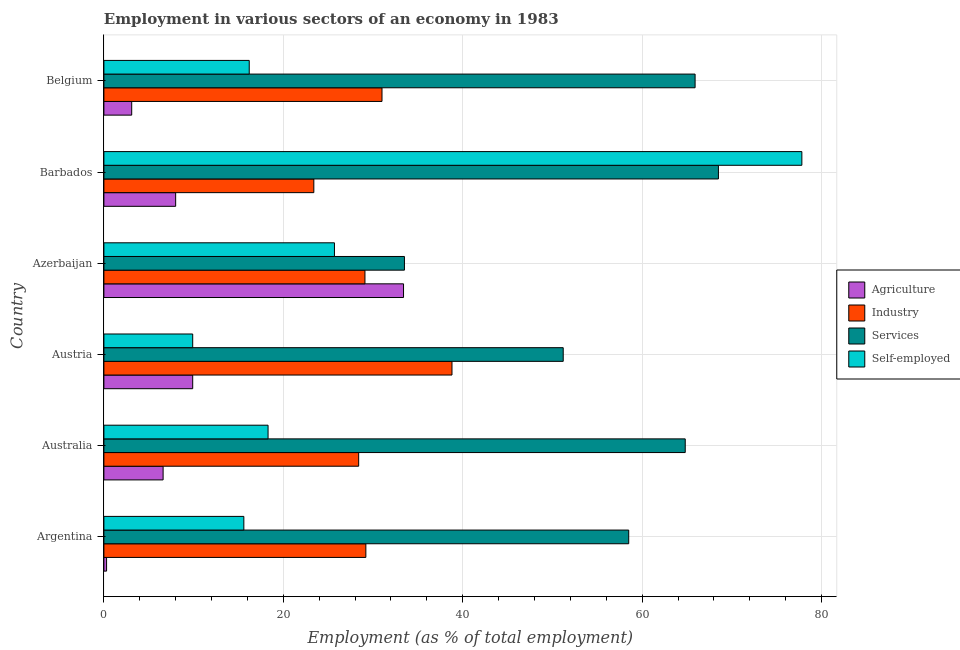How many different coloured bars are there?
Your response must be concise. 4. Are the number of bars on each tick of the Y-axis equal?
Offer a very short reply. Yes. How many bars are there on the 2nd tick from the bottom?
Your answer should be compact. 4. What is the label of the 5th group of bars from the top?
Your answer should be compact. Australia. In how many cases, is the number of bars for a given country not equal to the number of legend labels?
Keep it short and to the point. 0. What is the percentage of workers in industry in Azerbaijan?
Your answer should be compact. 29.1. Across all countries, what is the maximum percentage of self employed workers?
Provide a succinct answer. 77.8. Across all countries, what is the minimum percentage of workers in services?
Your answer should be very brief. 33.5. In which country was the percentage of workers in agriculture minimum?
Keep it short and to the point. Argentina. What is the total percentage of workers in agriculture in the graph?
Offer a terse response. 61.3. What is the difference between the percentage of workers in industry in Argentina and the percentage of workers in services in Azerbaijan?
Provide a succinct answer. -4.3. What is the average percentage of self employed workers per country?
Provide a short and direct response. 27.25. What is the difference between the percentage of self employed workers and percentage of workers in industry in Australia?
Your answer should be very brief. -10.1. What is the ratio of the percentage of workers in services in Argentina to that in Belgium?
Ensure brevity in your answer.  0.89. Is the percentage of workers in industry in Australia less than that in Barbados?
Offer a very short reply. No. What is the difference between the highest and the second highest percentage of workers in industry?
Your response must be concise. 7.8. In how many countries, is the percentage of workers in agriculture greater than the average percentage of workers in agriculture taken over all countries?
Offer a very short reply. 1. Is the sum of the percentage of workers in services in Azerbaijan and Belgium greater than the maximum percentage of workers in agriculture across all countries?
Your answer should be compact. Yes. Is it the case that in every country, the sum of the percentage of workers in agriculture and percentage of workers in services is greater than the sum of percentage of self employed workers and percentage of workers in industry?
Give a very brief answer. Yes. What does the 4th bar from the top in Austria represents?
Offer a very short reply. Agriculture. What does the 2nd bar from the bottom in Australia represents?
Provide a succinct answer. Industry. How many bars are there?
Your answer should be compact. 24. Are all the bars in the graph horizontal?
Make the answer very short. Yes. How many countries are there in the graph?
Your answer should be compact. 6. What is the difference between two consecutive major ticks on the X-axis?
Make the answer very short. 20. Are the values on the major ticks of X-axis written in scientific E-notation?
Your answer should be compact. No. Does the graph contain any zero values?
Give a very brief answer. No. Where does the legend appear in the graph?
Your answer should be very brief. Center right. How many legend labels are there?
Keep it short and to the point. 4. How are the legend labels stacked?
Give a very brief answer. Vertical. What is the title of the graph?
Provide a succinct answer. Employment in various sectors of an economy in 1983. Does "Plant species" appear as one of the legend labels in the graph?
Give a very brief answer. No. What is the label or title of the X-axis?
Ensure brevity in your answer.  Employment (as % of total employment). What is the label or title of the Y-axis?
Keep it short and to the point. Country. What is the Employment (as % of total employment) in Agriculture in Argentina?
Make the answer very short. 0.3. What is the Employment (as % of total employment) of Industry in Argentina?
Provide a succinct answer. 29.2. What is the Employment (as % of total employment) in Services in Argentina?
Provide a succinct answer. 58.5. What is the Employment (as % of total employment) of Self-employed in Argentina?
Your answer should be very brief. 15.6. What is the Employment (as % of total employment) in Agriculture in Australia?
Keep it short and to the point. 6.6. What is the Employment (as % of total employment) of Industry in Australia?
Offer a terse response. 28.4. What is the Employment (as % of total employment) of Services in Australia?
Give a very brief answer. 64.8. What is the Employment (as % of total employment) in Self-employed in Australia?
Your response must be concise. 18.3. What is the Employment (as % of total employment) in Agriculture in Austria?
Ensure brevity in your answer.  9.9. What is the Employment (as % of total employment) in Industry in Austria?
Keep it short and to the point. 38.8. What is the Employment (as % of total employment) of Services in Austria?
Your answer should be very brief. 51.2. What is the Employment (as % of total employment) in Self-employed in Austria?
Your response must be concise. 9.9. What is the Employment (as % of total employment) in Agriculture in Azerbaijan?
Ensure brevity in your answer.  33.4. What is the Employment (as % of total employment) of Industry in Azerbaijan?
Offer a very short reply. 29.1. What is the Employment (as % of total employment) in Services in Azerbaijan?
Give a very brief answer. 33.5. What is the Employment (as % of total employment) of Self-employed in Azerbaijan?
Your answer should be very brief. 25.7. What is the Employment (as % of total employment) in Industry in Barbados?
Provide a short and direct response. 23.4. What is the Employment (as % of total employment) in Services in Barbados?
Give a very brief answer. 68.5. What is the Employment (as % of total employment) of Self-employed in Barbados?
Give a very brief answer. 77.8. What is the Employment (as % of total employment) of Agriculture in Belgium?
Offer a very short reply. 3.1. What is the Employment (as % of total employment) of Industry in Belgium?
Provide a short and direct response. 31. What is the Employment (as % of total employment) of Services in Belgium?
Ensure brevity in your answer.  65.9. What is the Employment (as % of total employment) in Self-employed in Belgium?
Your answer should be very brief. 16.2. Across all countries, what is the maximum Employment (as % of total employment) in Agriculture?
Offer a very short reply. 33.4. Across all countries, what is the maximum Employment (as % of total employment) of Industry?
Make the answer very short. 38.8. Across all countries, what is the maximum Employment (as % of total employment) in Services?
Your response must be concise. 68.5. Across all countries, what is the maximum Employment (as % of total employment) of Self-employed?
Offer a terse response. 77.8. Across all countries, what is the minimum Employment (as % of total employment) in Agriculture?
Make the answer very short. 0.3. Across all countries, what is the minimum Employment (as % of total employment) in Industry?
Provide a succinct answer. 23.4. Across all countries, what is the minimum Employment (as % of total employment) of Services?
Provide a succinct answer. 33.5. Across all countries, what is the minimum Employment (as % of total employment) in Self-employed?
Your answer should be very brief. 9.9. What is the total Employment (as % of total employment) in Agriculture in the graph?
Offer a very short reply. 61.3. What is the total Employment (as % of total employment) of Industry in the graph?
Make the answer very short. 179.9. What is the total Employment (as % of total employment) in Services in the graph?
Make the answer very short. 342.4. What is the total Employment (as % of total employment) in Self-employed in the graph?
Provide a succinct answer. 163.5. What is the difference between the Employment (as % of total employment) in Agriculture in Argentina and that in Australia?
Keep it short and to the point. -6.3. What is the difference between the Employment (as % of total employment) of Industry in Argentina and that in Australia?
Your answer should be very brief. 0.8. What is the difference between the Employment (as % of total employment) of Self-employed in Argentina and that in Austria?
Your answer should be very brief. 5.7. What is the difference between the Employment (as % of total employment) in Agriculture in Argentina and that in Azerbaijan?
Provide a short and direct response. -33.1. What is the difference between the Employment (as % of total employment) of Self-employed in Argentina and that in Azerbaijan?
Provide a short and direct response. -10.1. What is the difference between the Employment (as % of total employment) in Industry in Argentina and that in Barbados?
Offer a very short reply. 5.8. What is the difference between the Employment (as % of total employment) in Self-employed in Argentina and that in Barbados?
Your answer should be very brief. -62.2. What is the difference between the Employment (as % of total employment) in Agriculture in Argentina and that in Belgium?
Your response must be concise. -2.8. What is the difference between the Employment (as % of total employment) in Industry in Argentina and that in Belgium?
Your response must be concise. -1.8. What is the difference between the Employment (as % of total employment) of Services in Argentina and that in Belgium?
Offer a terse response. -7.4. What is the difference between the Employment (as % of total employment) of Self-employed in Argentina and that in Belgium?
Offer a very short reply. -0.6. What is the difference between the Employment (as % of total employment) of Agriculture in Australia and that in Austria?
Your response must be concise. -3.3. What is the difference between the Employment (as % of total employment) of Industry in Australia and that in Austria?
Keep it short and to the point. -10.4. What is the difference between the Employment (as % of total employment) of Services in Australia and that in Austria?
Provide a succinct answer. 13.6. What is the difference between the Employment (as % of total employment) of Agriculture in Australia and that in Azerbaijan?
Your answer should be compact. -26.8. What is the difference between the Employment (as % of total employment) in Industry in Australia and that in Azerbaijan?
Ensure brevity in your answer.  -0.7. What is the difference between the Employment (as % of total employment) of Services in Australia and that in Azerbaijan?
Your answer should be compact. 31.3. What is the difference between the Employment (as % of total employment) of Self-employed in Australia and that in Azerbaijan?
Offer a terse response. -7.4. What is the difference between the Employment (as % of total employment) in Industry in Australia and that in Barbados?
Provide a succinct answer. 5. What is the difference between the Employment (as % of total employment) of Services in Australia and that in Barbados?
Give a very brief answer. -3.7. What is the difference between the Employment (as % of total employment) in Self-employed in Australia and that in Barbados?
Your answer should be very brief. -59.5. What is the difference between the Employment (as % of total employment) in Agriculture in Australia and that in Belgium?
Give a very brief answer. 3.5. What is the difference between the Employment (as % of total employment) in Agriculture in Austria and that in Azerbaijan?
Your answer should be very brief. -23.5. What is the difference between the Employment (as % of total employment) of Industry in Austria and that in Azerbaijan?
Ensure brevity in your answer.  9.7. What is the difference between the Employment (as % of total employment) of Self-employed in Austria and that in Azerbaijan?
Ensure brevity in your answer.  -15.8. What is the difference between the Employment (as % of total employment) of Agriculture in Austria and that in Barbados?
Offer a terse response. 1.9. What is the difference between the Employment (as % of total employment) of Industry in Austria and that in Barbados?
Keep it short and to the point. 15.4. What is the difference between the Employment (as % of total employment) of Services in Austria and that in Barbados?
Your answer should be very brief. -17.3. What is the difference between the Employment (as % of total employment) of Self-employed in Austria and that in Barbados?
Provide a short and direct response. -67.9. What is the difference between the Employment (as % of total employment) of Services in Austria and that in Belgium?
Your response must be concise. -14.7. What is the difference between the Employment (as % of total employment) in Self-employed in Austria and that in Belgium?
Provide a short and direct response. -6.3. What is the difference between the Employment (as % of total employment) in Agriculture in Azerbaijan and that in Barbados?
Your response must be concise. 25.4. What is the difference between the Employment (as % of total employment) in Industry in Azerbaijan and that in Barbados?
Make the answer very short. 5.7. What is the difference between the Employment (as % of total employment) of Services in Azerbaijan and that in Barbados?
Offer a very short reply. -35. What is the difference between the Employment (as % of total employment) of Self-employed in Azerbaijan and that in Barbados?
Your response must be concise. -52.1. What is the difference between the Employment (as % of total employment) of Agriculture in Azerbaijan and that in Belgium?
Offer a very short reply. 30.3. What is the difference between the Employment (as % of total employment) in Services in Azerbaijan and that in Belgium?
Offer a terse response. -32.4. What is the difference between the Employment (as % of total employment) of Services in Barbados and that in Belgium?
Your answer should be very brief. 2.6. What is the difference between the Employment (as % of total employment) of Self-employed in Barbados and that in Belgium?
Ensure brevity in your answer.  61.6. What is the difference between the Employment (as % of total employment) of Agriculture in Argentina and the Employment (as % of total employment) of Industry in Australia?
Provide a short and direct response. -28.1. What is the difference between the Employment (as % of total employment) in Agriculture in Argentina and the Employment (as % of total employment) in Services in Australia?
Your response must be concise. -64.5. What is the difference between the Employment (as % of total employment) of Agriculture in Argentina and the Employment (as % of total employment) of Self-employed in Australia?
Your response must be concise. -18. What is the difference between the Employment (as % of total employment) in Industry in Argentina and the Employment (as % of total employment) in Services in Australia?
Give a very brief answer. -35.6. What is the difference between the Employment (as % of total employment) in Industry in Argentina and the Employment (as % of total employment) in Self-employed in Australia?
Ensure brevity in your answer.  10.9. What is the difference between the Employment (as % of total employment) of Services in Argentina and the Employment (as % of total employment) of Self-employed in Australia?
Your response must be concise. 40.2. What is the difference between the Employment (as % of total employment) of Agriculture in Argentina and the Employment (as % of total employment) of Industry in Austria?
Your answer should be compact. -38.5. What is the difference between the Employment (as % of total employment) in Agriculture in Argentina and the Employment (as % of total employment) in Services in Austria?
Keep it short and to the point. -50.9. What is the difference between the Employment (as % of total employment) of Agriculture in Argentina and the Employment (as % of total employment) of Self-employed in Austria?
Your answer should be very brief. -9.6. What is the difference between the Employment (as % of total employment) in Industry in Argentina and the Employment (as % of total employment) in Services in Austria?
Give a very brief answer. -22. What is the difference between the Employment (as % of total employment) of Industry in Argentina and the Employment (as % of total employment) of Self-employed in Austria?
Your response must be concise. 19.3. What is the difference between the Employment (as % of total employment) of Services in Argentina and the Employment (as % of total employment) of Self-employed in Austria?
Your response must be concise. 48.6. What is the difference between the Employment (as % of total employment) in Agriculture in Argentina and the Employment (as % of total employment) in Industry in Azerbaijan?
Provide a short and direct response. -28.8. What is the difference between the Employment (as % of total employment) in Agriculture in Argentina and the Employment (as % of total employment) in Services in Azerbaijan?
Offer a terse response. -33.2. What is the difference between the Employment (as % of total employment) in Agriculture in Argentina and the Employment (as % of total employment) in Self-employed in Azerbaijan?
Your response must be concise. -25.4. What is the difference between the Employment (as % of total employment) of Industry in Argentina and the Employment (as % of total employment) of Self-employed in Azerbaijan?
Your answer should be compact. 3.5. What is the difference between the Employment (as % of total employment) in Services in Argentina and the Employment (as % of total employment) in Self-employed in Azerbaijan?
Your answer should be very brief. 32.8. What is the difference between the Employment (as % of total employment) of Agriculture in Argentina and the Employment (as % of total employment) of Industry in Barbados?
Your response must be concise. -23.1. What is the difference between the Employment (as % of total employment) in Agriculture in Argentina and the Employment (as % of total employment) in Services in Barbados?
Your response must be concise. -68.2. What is the difference between the Employment (as % of total employment) of Agriculture in Argentina and the Employment (as % of total employment) of Self-employed in Barbados?
Keep it short and to the point. -77.5. What is the difference between the Employment (as % of total employment) of Industry in Argentina and the Employment (as % of total employment) of Services in Barbados?
Ensure brevity in your answer.  -39.3. What is the difference between the Employment (as % of total employment) in Industry in Argentina and the Employment (as % of total employment) in Self-employed in Barbados?
Offer a terse response. -48.6. What is the difference between the Employment (as % of total employment) of Services in Argentina and the Employment (as % of total employment) of Self-employed in Barbados?
Your answer should be very brief. -19.3. What is the difference between the Employment (as % of total employment) in Agriculture in Argentina and the Employment (as % of total employment) in Industry in Belgium?
Ensure brevity in your answer.  -30.7. What is the difference between the Employment (as % of total employment) in Agriculture in Argentina and the Employment (as % of total employment) in Services in Belgium?
Your response must be concise. -65.6. What is the difference between the Employment (as % of total employment) in Agriculture in Argentina and the Employment (as % of total employment) in Self-employed in Belgium?
Provide a succinct answer. -15.9. What is the difference between the Employment (as % of total employment) of Industry in Argentina and the Employment (as % of total employment) of Services in Belgium?
Offer a very short reply. -36.7. What is the difference between the Employment (as % of total employment) of Services in Argentina and the Employment (as % of total employment) of Self-employed in Belgium?
Keep it short and to the point. 42.3. What is the difference between the Employment (as % of total employment) in Agriculture in Australia and the Employment (as % of total employment) in Industry in Austria?
Provide a succinct answer. -32.2. What is the difference between the Employment (as % of total employment) in Agriculture in Australia and the Employment (as % of total employment) in Services in Austria?
Ensure brevity in your answer.  -44.6. What is the difference between the Employment (as % of total employment) of Industry in Australia and the Employment (as % of total employment) of Services in Austria?
Provide a succinct answer. -22.8. What is the difference between the Employment (as % of total employment) of Services in Australia and the Employment (as % of total employment) of Self-employed in Austria?
Offer a terse response. 54.9. What is the difference between the Employment (as % of total employment) of Agriculture in Australia and the Employment (as % of total employment) of Industry in Azerbaijan?
Offer a very short reply. -22.5. What is the difference between the Employment (as % of total employment) in Agriculture in Australia and the Employment (as % of total employment) in Services in Azerbaijan?
Your response must be concise. -26.9. What is the difference between the Employment (as % of total employment) of Agriculture in Australia and the Employment (as % of total employment) of Self-employed in Azerbaijan?
Offer a very short reply. -19.1. What is the difference between the Employment (as % of total employment) in Industry in Australia and the Employment (as % of total employment) in Services in Azerbaijan?
Ensure brevity in your answer.  -5.1. What is the difference between the Employment (as % of total employment) in Industry in Australia and the Employment (as % of total employment) in Self-employed in Azerbaijan?
Give a very brief answer. 2.7. What is the difference between the Employment (as % of total employment) in Services in Australia and the Employment (as % of total employment) in Self-employed in Azerbaijan?
Ensure brevity in your answer.  39.1. What is the difference between the Employment (as % of total employment) of Agriculture in Australia and the Employment (as % of total employment) of Industry in Barbados?
Your answer should be very brief. -16.8. What is the difference between the Employment (as % of total employment) of Agriculture in Australia and the Employment (as % of total employment) of Services in Barbados?
Keep it short and to the point. -61.9. What is the difference between the Employment (as % of total employment) of Agriculture in Australia and the Employment (as % of total employment) of Self-employed in Barbados?
Your answer should be very brief. -71.2. What is the difference between the Employment (as % of total employment) of Industry in Australia and the Employment (as % of total employment) of Services in Barbados?
Give a very brief answer. -40.1. What is the difference between the Employment (as % of total employment) of Industry in Australia and the Employment (as % of total employment) of Self-employed in Barbados?
Give a very brief answer. -49.4. What is the difference between the Employment (as % of total employment) in Agriculture in Australia and the Employment (as % of total employment) in Industry in Belgium?
Your answer should be compact. -24.4. What is the difference between the Employment (as % of total employment) of Agriculture in Australia and the Employment (as % of total employment) of Services in Belgium?
Your answer should be very brief. -59.3. What is the difference between the Employment (as % of total employment) in Agriculture in Australia and the Employment (as % of total employment) in Self-employed in Belgium?
Offer a terse response. -9.6. What is the difference between the Employment (as % of total employment) in Industry in Australia and the Employment (as % of total employment) in Services in Belgium?
Offer a terse response. -37.5. What is the difference between the Employment (as % of total employment) in Services in Australia and the Employment (as % of total employment) in Self-employed in Belgium?
Ensure brevity in your answer.  48.6. What is the difference between the Employment (as % of total employment) in Agriculture in Austria and the Employment (as % of total employment) in Industry in Azerbaijan?
Provide a succinct answer. -19.2. What is the difference between the Employment (as % of total employment) in Agriculture in Austria and the Employment (as % of total employment) in Services in Azerbaijan?
Your answer should be very brief. -23.6. What is the difference between the Employment (as % of total employment) in Agriculture in Austria and the Employment (as % of total employment) in Self-employed in Azerbaijan?
Offer a very short reply. -15.8. What is the difference between the Employment (as % of total employment) of Industry in Austria and the Employment (as % of total employment) of Services in Azerbaijan?
Make the answer very short. 5.3. What is the difference between the Employment (as % of total employment) of Industry in Austria and the Employment (as % of total employment) of Self-employed in Azerbaijan?
Make the answer very short. 13.1. What is the difference between the Employment (as % of total employment) in Agriculture in Austria and the Employment (as % of total employment) in Industry in Barbados?
Your answer should be compact. -13.5. What is the difference between the Employment (as % of total employment) of Agriculture in Austria and the Employment (as % of total employment) of Services in Barbados?
Your response must be concise. -58.6. What is the difference between the Employment (as % of total employment) in Agriculture in Austria and the Employment (as % of total employment) in Self-employed in Barbados?
Offer a very short reply. -67.9. What is the difference between the Employment (as % of total employment) in Industry in Austria and the Employment (as % of total employment) in Services in Barbados?
Provide a short and direct response. -29.7. What is the difference between the Employment (as % of total employment) of Industry in Austria and the Employment (as % of total employment) of Self-employed in Barbados?
Your response must be concise. -39. What is the difference between the Employment (as % of total employment) in Services in Austria and the Employment (as % of total employment) in Self-employed in Barbados?
Your answer should be very brief. -26.6. What is the difference between the Employment (as % of total employment) in Agriculture in Austria and the Employment (as % of total employment) in Industry in Belgium?
Your response must be concise. -21.1. What is the difference between the Employment (as % of total employment) of Agriculture in Austria and the Employment (as % of total employment) of Services in Belgium?
Offer a terse response. -56. What is the difference between the Employment (as % of total employment) in Industry in Austria and the Employment (as % of total employment) in Services in Belgium?
Ensure brevity in your answer.  -27.1. What is the difference between the Employment (as % of total employment) of Industry in Austria and the Employment (as % of total employment) of Self-employed in Belgium?
Your response must be concise. 22.6. What is the difference between the Employment (as % of total employment) in Services in Austria and the Employment (as % of total employment) in Self-employed in Belgium?
Your response must be concise. 35. What is the difference between the Employment (as % of total employment) of Agriculture in Azerbaijan and the Employment (as % of total employment) of Industry in Barbados?
Provide a short and direct response. 10. What is the difference between the Employment (as % of total employment) of Agriculture in Azerbaijan and the Employment (as % of total employment) of Services in Barbados?
Your response must be concise. -35.1. What is the difference between the Employment (as % of total employment) in Agriculture in Azerbaijan and the Employment (as % of total employment) in Self-employed in Barbados?
Your answer should be compact. -44.4. What is the difference between the Employment (as % of total employment) in Industry in Azerbaijan and the Employment (as % of total employment) in Services in Barbados?
Make the answer very short. -39.4. What is the difference between the Employment (as % of total employment) in Industry in Azerbaijan and the Employment (as % of total employment) in Self-employed in Barbados?
Your answer should be very brief. -48.7. What is the difference between the Employment (as % of total employment) in Services in Azerbaijan and the Employment (as % of total employment) in Self-employed in Barbados?
Your answer should be compact. -44.3. What is the difference between the Employment (as % of total employment) in Agriculture in Azerbaijan and the Employment (as % of total employment) in Services in Belgium?
Your answer should be very brief. -32.5. What is the difference between the Employment (as % of total employment) of Agriculture in Azerbaijan and the Employment (as % of total employment) of Self-employed in Belgium?
Offer a very short reply. 17.2. What is the difference between the Employment (as % of total employment) of Industry in Azerbaijan and the Employment (as % of total employment) of Services in Belgium?
Provide a short and direct response. -36.8. What is the difference between the Employment (as % of total employment) of Industry in Azerbaijan and the Employment (as % of total employment) of Self-employed in Belgium?
Your answer should be compact. 12.9. What is the difference between the Employment (as % of total employment) in Services in Azerbaijan and the Employment (as % of total employment) in Self-employed in Belgium?
Offer a very short reply. 17.3. What is the difference between the Employment (as % of total employment) of Agriculture in Barbados and the Employment (as % of total employment) of Services in Belgium?
Give a very brief answer. -57.9. What is the difference between the Employment (as % of total employment) in Industry in Barbados and the Employment (as % of total employment) in Services in Belgium?
Offer a very short reply. -42.5. What is the difference between the Employment (as % of total employment) of Services in Barbados and the Employment (as % of total employment) of Self-employed in Belgium?
Keep it short and to the point. 52.3. What is the average Employment (as % of total employment) of Agriculture per country?
Provide a short and direct response. 10.22. What is the average Employment (as % of total employment) in Industry per country?
Offer a terse response. 29.98. What is the average Employment (as % of total employment) in Services per country?
Give a very brief answer. 57.07. What is the average Employment (as % of total employment) of Self-employed per country?
Your answer should be very brief. 27.25. What is the difference between the Employment (as % of total employment) of Agriculture and Employment (as % of total employment) of Industry in Argentina?
Provide a succinct answer. -28.9. What is the difference between the Employment (as % of total employment) of Agriculture and Employment (as % of total employment) of Services in Argentina?
Keep it short and to the point. -58.2. What is the difference between the Employment (as % of total employment) of Agriculture and Employment (as % of total employment) of Self-employed in Argentina?
Make the answer very short. -15.3. What is the difference between the Employment (as % of total employment) in Industry and Employment (as % of total employment) in Services in Argentina?
Offer a terse response. -29.3. What is the difference between the Employment (as % of total employment) in Services and Employment (as % of total employment) in Self-employed in Argentina?
Make the answer very short. 42.9. What is the difference between the Employment (as % of total employment) of Agriculture and Employment (as % of total employment) of Industry in Australia?
Offer a very short reply. -21.8. What is the difference between the Employment (as % of total employment) of Agriculture and Employment (as % of total employment) of Services in Australia?
Make the answer very short. -58.2. What is the difference between the Employment (as % of total employment) of Agriculture and Employment (as % of total employment) of Self-employed in Australia?
Provide a succinct answer. -11.7. What is the difference between the Employment (as % of total employment) of Industry and Employment (as % of total employment) of Services in Australia?
Your answer should be compact. -36.4. What is the difference between the Employment (as % of total employment) of Industry and Employment (as % of total employment) of Self-employed in Australia?
Keep it short and to the point. 10.1. What is the difference between the Employment (as % of total employment) in Services and Employment (as % of total employment) in Self-employed in Australia?
Keep it short and to the point. 46.5. What is the difference between the Employment (as % of total employment) in Agriculture and Employment (as % of total employment) in Industry in Austria?
Offer a terse response. -28.9. What is the difference between the Employment (as % of total employment) in Agriculture and Employment (as % of total employment) in Services in Austria?
Offer a very short reply. -41.3. What is the difference between the Employment (as % of total employment) in Agriculture and Employment (as % of total employment) in Self-employed in Austria?
Provide a succinct answer. 0. What is the difference between the Employment (as % of total employment) of Industry and Employment (as % of total employment) of Services in Austria?
Your answer should be very brief. -12.4. What is the difference between the Employment (as % of total employment) of Industry and Employment (as % of total employment) of Self-employed in Austria?
Your response must be concise. 28.9. What is the difference between the Employment (as % of total employment) in Services and Employment (as % of total employment) in Self-employed in Austria?
Provide a succinct answer. 41.3. What is the difference between the Employment (as % of total employment) in Agriculture and Employment (as % of total employment) in Industry in Azerbaijan?
Provide a succinct answer. 4.3. What is the difference between the Employment (as % of total employment) of Agriculture and Employment (as % of total employment) of Self-employed in Azerbaijan?
Keep it short and to the point. 7.7. What is the difference between the Employment (as % of total employment) in Agriculture and Employment (as % of total employment) in Industry in Barbados?
Provide a short and direct response. -15.4. What is the difference between the Employment (as % of total employment) in Agriculture and Employment (as % of total employment) in Services in Barbados?
Ensure brevity in your answer.  -60.5. What is the difference between the Employment (as % of total employment) of Agriculture and Employment (as % of total employment) of Self-employed in Barbados?
Make the answer very short. -69.8. What is the difference between the Employment (as % of total employment) of Industry and Employment (as % of total employment) of Services in Barbados?
Your response must be concise. -45.1. What is the difference between the Employment (as % of total employment) of Industry and Employment (as % of total employment) of Self-employed in Barbados?
Provide a succinct answer. -54.4. What is the difference between the Employment (as % of total employment) of Agriculture and Employment (as % of total employment) of Industry in Belgium?
Make the answer very short. -27.9. What is the difference between the Employment (as % of total employment) of Agriculture and Employment (as % of total employment) of Services in Belgium?
Make the answer very short. -62.8. What is the difference between the Employment (as % of total employment) of Industry and Employment (as % of total employment) of Services in Belgium?
Offer a very short reply. -34.9. What is the difference between the Employment (as % of total employment) in Industry and Employment (as % of total employment) in Self-employed in Belgium?
Make the answer very short. 14.8. What is the difference between the Employment (as % of total employment) in Services and Employment (as % of total employment) in Self-employed in Belgium?
Make the answer very short. 49.7. What is the ratio of the Employment (as % of total employment) of Agriculture in Argentina to that in Australia?
Your answer should be compact. 0.05. What is the ratio of the Employment (as % of total employment) in Industry in Argentina to that in Australia?
Keep it short and to the point. 1.03. What is the ratio of the Employment (as % of total employment) in Services in Argentina to that in Australia?
Keep it short and to the point. 0.9. What is the ratio of the Employment (as % of total employment) of Self-employed in Argentina to that in Australia?
Make the answer very short. 0.85. What is the ratio of the Employment (as % of total employment) in Agriculture in Argentina to that in Austria?
Your answer should be very brief. 0.03. What is the ratio of the Employment (as % of total employment) in Industry in Argentina to that in Austria?
Your response must be concise. 0.75. What is the ratio of the Employment (as % of total employment) of Services in Argentina to that in Austria?
Offer a very short reply. 1.14. What is the ratio of the Employment (as % of total employment) in Self-employed in Argentina to that in Austria?
Provide a short and direct response. 1.58. What is the ratio of the Employment (as % of total employment) of Agriculture in Argentina to that in Azerbaijan?
Provide a succinct answer. 0.01. What is the ratio of the Employment (as % of total employment) in Services in Argentina to that in Azerbaijan?
Offer a very short reply. 1.75. What is the ratio of the Employment (as % of total employment) of Self-employed in Argentina to that in Azerbaijan?
Your response must be concise. 0.61. What is the ratio of the Employment (as % of total employment) in Agriculture in Argentina to that in Barbados?
Give a very brief answer. 0.04. What is the ratio of the Employment (as % of total employment) in Industry in Argentina to that in Barbados?
Ensure brevity in your answer.  1.25. What is the ratio of the Employment (as % of total employment) in Services in Argentina to that in Barbados?
Provide a succinct answer. 0.85. What is the ratio of the Employment (as % of total employment) in Self-employed in Argentina to that in Barbados?
Ensure brevity in your answer.  0.2. What is the ratio of the Employment (as % of total employment) of Agriculture in Argentina to that in Belgium?
Offer a terse response. 0.1. What is the ratio of the Employment (as % of total employment) of Industry in Argentina to that in Belgium?
Provide a succinct answer. 0.94. What is the ratio of the Employment (as % of total employment) of Services in Argentina to that in Belgium?
Ensure brevity in your answer.  0.89. What is the ratio of the Employment (as % of total employment) in Self-employed in Argentina to that in Belgium?
Your response must be concise. 0.96. What is the ratio of the Employment (as % of total employment) of Industry in Australia to that in Austria?
Your answer should be compact. 0.73. What is the ratio of the Employment (as % of total employment) in Services in Australia to that in Austria?
Make the answer very short. 1.27. What is the ratio of the Employment (as % of total employment) in Self-employed in Australia to that in Austria?
Keep it short and to the point. 1.85. What is the ratio of the Employment (as % of total employment) in Agriculture in Australia to that in Azerbaijan?
Make the answer very short. 0.2. What is the ratio of the Employment (as % of total employment) in Industry in Australia to that in Azerbaijan?
Your answer should be very brief. 0.98. What is the ratio of the Employment (as % of total employment) in Services in Australia to that in Azerbaijan?
Give a very brief answer. 1.93. What is the ratio of the Employment (as % of total employment) in Self-employed in Australia to that in Azerbaijan?
Offer a very short reply. 0.71. What is the ratio of the Employment (as % of total employment) in Agriculture in Australia to that in Barbados?
Your answer should be very brief. 0.82. What is the ratio of the Employment (as % of total employment) in Industry in Australia to that in Barbados?
Offer a very short reply. 1.21. What is the ratio of the Employment (as % of total employment) in Services in Australia to that in Barbados?
Keep it short and to the point. 0.95. What is the ratio of the Employment (as % of total employment) of Self-employed in Australia to that in Barbados?
Offer a very short reply. 0.24. What is the ratio of the Employment (as % of total employment) in Agriculture in Australia to that in Belgium?
Your answer should be compact. 2.13. What is the ratio of the Employment (as % of total employment) of Industry in Australia to that in Belgium?
Your answer should be compact. 0.92. What is the ratio of the Employment (as % of total employment) of Services in Australia to that in Belgium?
Keep it short and to the point. 0.98. What is the ratio of the Employment (as % of total employment) in Self-employed in Australia to that in Belgium?
Your response must be concise. 1.13. What is the ratio of the Employment (as % of total employment) in Agriculture in Austria to that in Azerbaijan?
Give a very brief answer. 0.3. What is the ratio of the Employment (as % of total employment) of Services in Austria to that in Azerbaijan?
Ensure brevity in your answer.  1.53. What is the ratio of the Employment (as % of total employment) of Self-employed in Austria to that in Azerbaijan?
Give a very brief answer. 0.39. What is the ratio of the Employment (as % of total employment) of Agriculture in Austria to that in Barbados?
Offer a very short reply. 1.24. What is the ratio of the Employment (as % of total employment) in Industry in Austria to that in Barbados?
Offer a terse response. 1.66. What is the ratio of the Employment (as % of total employment) in Services in Austria to that in Barbados?
Provide a short and direct response. 0.75. What is the ratio of the Employment (as % of total employment) in Self-employed in Austria to that in Barbados?
Offer a very short reply. 0.13. What is the ratio of the Employment (as % of total employment) in Agriculture in Austria to that in Belgium?
Offer a very short reply. 3.19. What is the ratio of the Employment (as % of total employment) of Industry in Austria to that in Belgium?
Offer a very short reply. 1.25. What is the ratio of the Employment (as % of total employment) of Services in Austria to that in Belgium?
Ensure brevity in your answer.  0.78. What is the ratio of the Employment (as % of total employment) of Self-employed in Austria to that in Belgium?
Your answer should be compact. 0.61. What is the ratio of the Employment (as % of total employment) in Agriculture in Azerbaijan to that in Barbados?
Give a very brief answer. 4.17. What is the ratio of the Employment (as % of total employment) in Industry in Azerbaijan to that in Barbados?
Provide a short and direct response. 1.24. What is the ratio of the Employment (as % of total employment) of Services in Azerbaijan to that in Barbados?
Offer a very short reply. 0.49. What is the ratio of the Employment (as % of total employment) of Self-employed in Azerbaijan to that in Barbados?
Your response must be concise. 0.33. What is the ratio of the Employment (as % of total employment) of Agriculture in Azerbaijan to that in Belgium?
Offer a terse response. 10.77. What is the ratio of the Employment (as % of total employment) of Industry in Azerbaijan to that in Belgium?
Offer a terse response. 0.94. What is the ratio of the Employment (as % of total employment) in Services in Azerbaijan to that in Belgium?
Your response must be concise. 0.51. What is the ratio of the Employment (as % of total employment) in Self-employed in Azerbaijan to that in Belgium?
Provide a short and direct response. 1.59. What is the ratio of the Employment (as % of total employment) in Agriculture in Barbados to that in Belgium?
Your response must be concise. 2.58. What is the ratio of the Employment (as % of total employment) of Industry in Barbados to that in Belgium?
Keep it short and to the point. 0.75. What is the ratio of the Employment (as % of total employment) of Services in Barbados to that in Belgium?
Offer a very short reply. 1.04. What is the ratio of the Employment (as % of total employment) in Self-employed in Barbados to that in Belgium?
Provide a short and direct response. 4.8. What is the difference between the highest and the second highest Employment (as % of total employment) of Self-employed?
Your answer should be compact. 52.1. What is the difference between the highest and the lowest Employment (as % of total employment) of Agriculture?
Give a very brief answer. 33.1. What is the difference between the highest and the lowest Employment (as % of total employment) in Industry?
Ensure brevity in your answer.  15.4. What is the difference between the highest and the lowest Employment (as % of total employment) in Services?
Your answer should be very brief. 35. What is the difference between the highest and the lowest Employment (as % of total employment) in Self-employed?
Give a very brief answer. 67.9. 